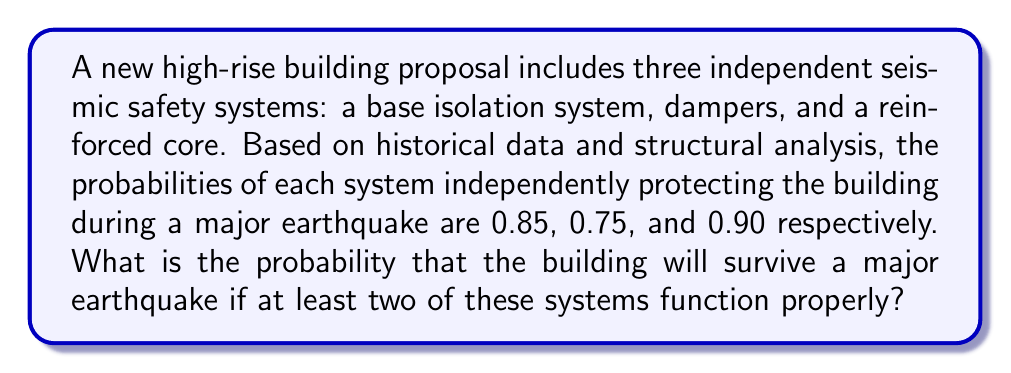Show me your answer to this math problem. Let's approach this step-by-step using the concept of complementary events and the inclusion-exclusion principle:

1) First, let's define our events:
   A: Base isolation system functions
   B: Dampers function
   C: Reinforced core functions

   P(A) = 0.85, P(B) = 0.75, P(C) = 0.90

2) We want the probability of at least two systems functioning. It's easier to calculate the complement of this event: the probability of zero or one system functioning.

3) Probability of zero systems functioning:
   $$P(\text{none}) = (1-0.85)(1-0.75)(1-0.90) = 0.15 \cdot 0.25 \cdot 0.10 = 0.00375$$

4) Probability of exactly one system functioning:
   $$P(\text{only A}) = 0.85 \cdot 0.25 \cdot 0.10 = 0.02125$$
   $$P(\text{only B}) = 0.15 \cdot 0.75 \cdot 0.10 = 0.01125$$
   $$P(\text{only C}) = 0.15 \cdot 0.25 \cdot 0.90 = 0.03375$$

   $$P(\text{exactly one}) = 0.02125 + 0.01125 + 0.03375 = 0.06625$$

5) Probability of zero or one system functioning:
   $$P(\text{zero or one}) = 0.00375 + 0.06625 = 0.07$$

6) Therefore, the probability of at least two systems functioning (and thus the building surviving) is:
   $$P(\text{at least two}) = 1 - P(\text{zero or one}) = 1 - 0.07 = 0.93$$
Answer: 0.93 